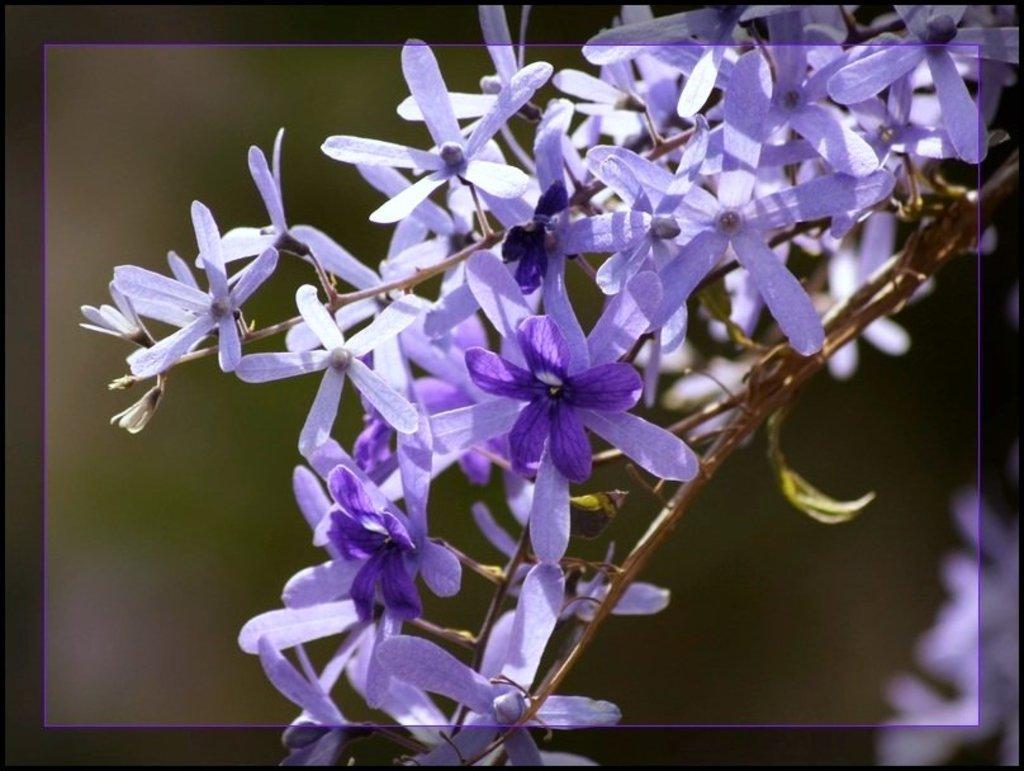Please provide a concise description of this image. These are the lavender flowers which are in purple color. 